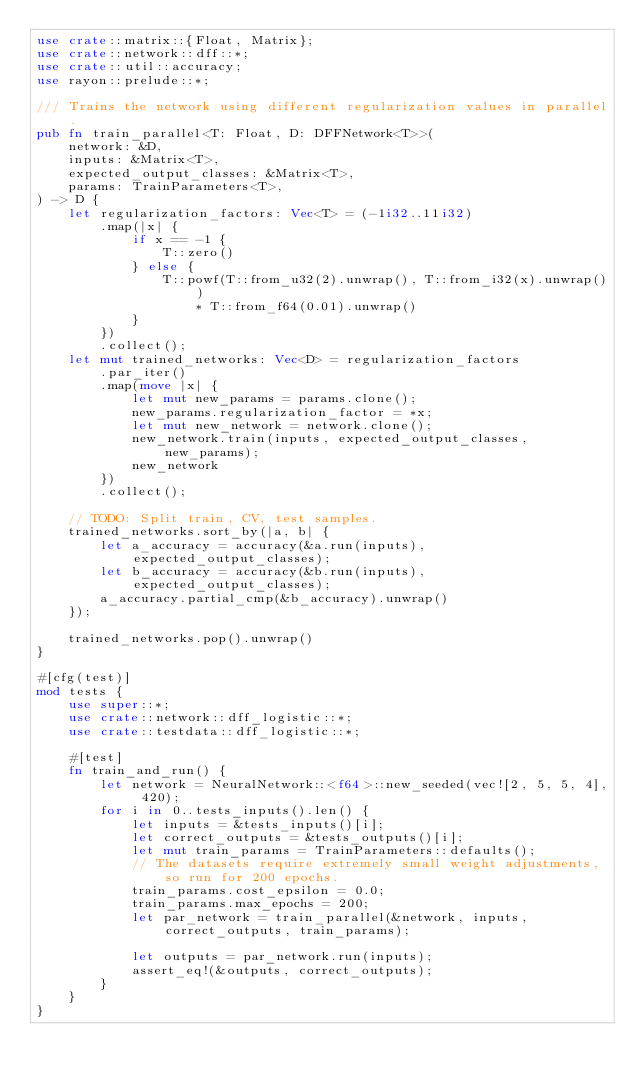Convert code to text. <code><loc_0><loc_0><loc_500><loc_500><_Rust_>use crate::matrix::{Float, Matrix};
use crate::network::dff::*;
use crate::util::accuracy;
use rayon::prelude::*;

/// Trains the network using different regularization values in parallel.
pub fn train_parallel<T: Float, D: DFFNetwork<T>>(
    network: &D,
    inputs: &Matrix<T>,
    expected_output_classes: &Matrix<T>,
    params: TrainParameters<T>,
) -> D {
    let regularization_factors: Vec<T> = (-1i32..11i32)
        .map(|x| {
            if x == -1 {
                T::zero()
            } else {
                T::powf(T::from_u32(2).unwrap(), T::from_i32(x).unwrap())
                    * T::from_f64(0.01).unwrap()
            }
        })
        .collect();
    let mut trained_networks: Vec<D> = regularization_factors
        .par_iter()
        .map(move |x| {
            let mut new_params = params.clone();
            new_params.regularization_factor = *x;
            let mut new_network = network.clone();
            new_network.train(inputs, expected_output_classes, new_params);
            new_network
        })
        .collect();

    // TODO: Split train, CV, test samples.
    trained_networks.sort_by(|a, b| {
        let a_accuracy = accuracy(&a.run(inputs), expected_output_classes);
        let b_accuracy = accuracy(&b.run(inputs), expected_output_classes);
        a_accuracy.partial_cmp(&b_accuracy).unwrap()
    });

    trained_networks.pop().unwrap()
}

#[cfg(test)]
mod tests {
    use super::*;
    use crate::network::dff_logistic::*;
    use crate::testdata::dff_logistic::*;

    #[test]
    fn train_and_run() {
        let network = NeuralNetwork::<f64>::new_seeded(vec![2, 5, 5, 4], 420);
        for i in 0..tests_inputs().len() {
            let inputs = &tests_inputs()[i];
            let correct_outputs = &tests_outputs()[i];
            let mut train_params = TrainParameters::defaults();
            // The datasets require extremely small weight adjustments, so run for 200 epochs.
            train_params.cost_epsilon = 0.0;
            train_params.max_epochs = 200;
            let par_network = train_parallel(&network, inputs, correct_outputs, train_params);

            let outputs = par_network.run(inputs);
            assert_eq!(&outputs, correct_outputs);
        }
    }
}
</code> 